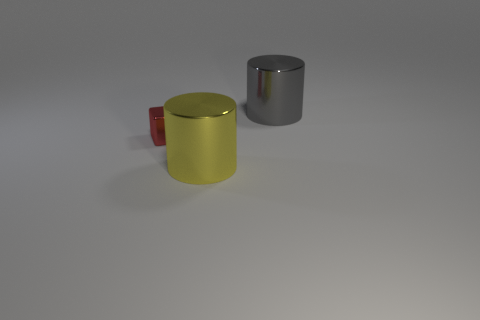How do the colors of the objects contribute to the overall aesthetics of the image? The contrasting colors of the objects - yellow, gray, and red - create a visually striking composition. The yellow and red add a pop of color, while the neutral gray balances the scene. Together, they catch the eye and could be arranged intentionally for artistic or design purposes. 